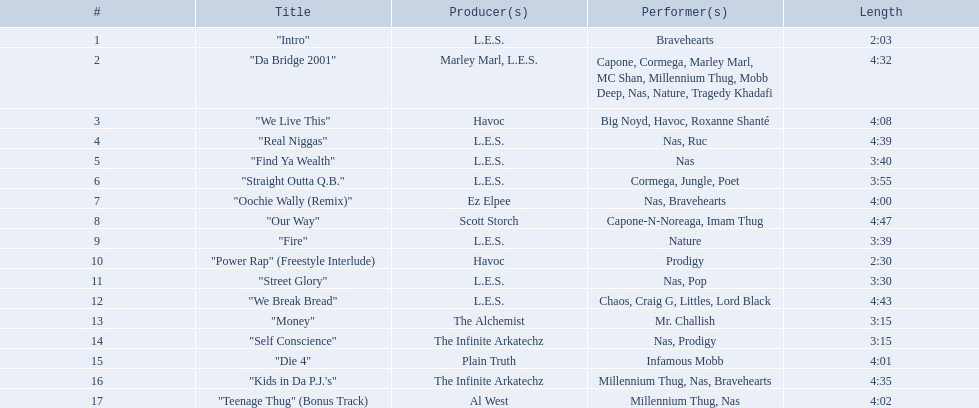How much time does each tune take? 2:03, 4:32, 4:08, 4:39, 3:40, 3:55, 4:00, 4:47, 3:39, 2:30, 3:30, 4:43, 3:15, 3:15, 4:01, 4:35, 4:02. Which one has the greatest length? 4:47. 